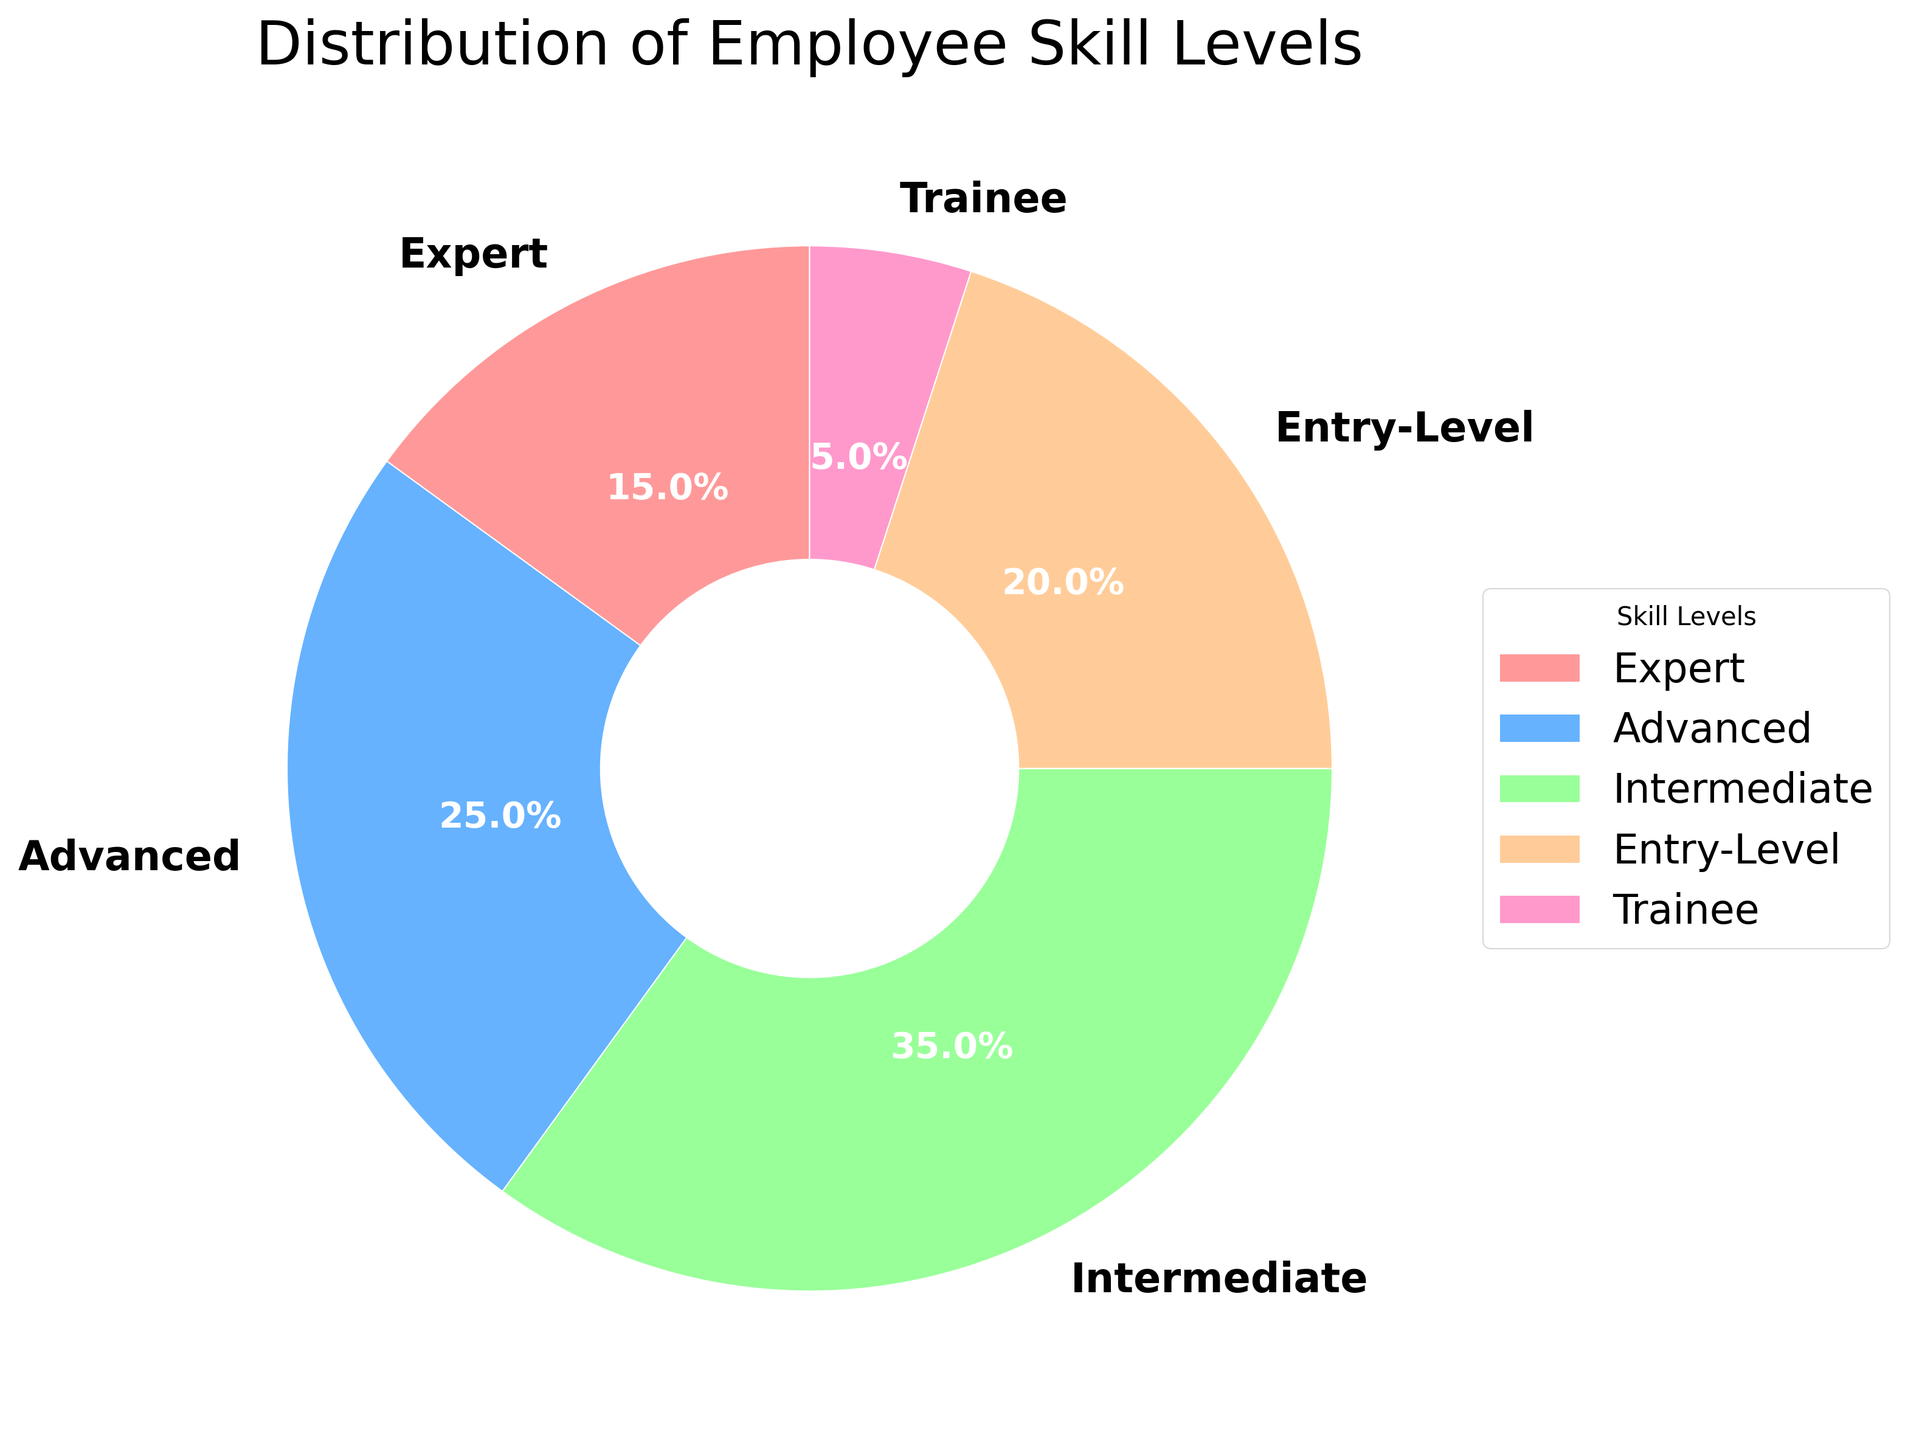What percentage of employees are classified as Entry-Level? The Entry-Level segment is indicated on the pie chart with a corresponding percentage. Locate the Entry-Level slice and read its label.
Answer: 20% Which skill level has the highest percentage of employees? Identify the slice with the largest size or highest percentage label on the pie chart to determine which skill level it represents.
Answer: Intermediate What is the combined percentage of employees in the Expert and Advanced skill levels? Locate the percentage values for both Expert and Advanced skill levels on the pie chart, and add them together: 15% (Expert) + 25% (Advanced).
Answer: 40% How does the percentage of Trainees compare to that of Experts? Identify the percentage values for both Trainee and Expert skill levels and compare them to see which is higher. Trainees are at 5%, and Experts are at 15%.
Answer: Less than What percentage of employees fall within the Intermediate or higher skill levels? Sum the percentages of the Intermediate, Advanced, and Expert skill levels: 35% (Intermediate) + 25% (Advanced) + 15% (Expert).
Answer: 75% Which segment of the pie chart is colored blue? Observe the colors used in the pie chart, and match the blue color to its corresponding label.
Answer: Advanced Is the percentage of Entry-Level employees greater than the combined percentage of Experts and Trainees? Add the percentages of Experts and Trainees: 15% (Experts) + 5% (Trainees) = 20%, then compare it with the percentage of Entry-Level employees (20%).
Answer: No What is the difference in percentage between Intermediate and Trainee skill levels? Subtract the percentage of Trainees from the percentage of Intermediates: 35% (Intermediate) - 5% (Trainee).
Answer: 30% How many skill levels have a percentage lower than the Intermediate skill level? Identify and count the skill levels with percentages lower than 35%: Expert (15%), Advanced (25%), Entry-Level (20%), Trainee (5%).
Answer: 4 